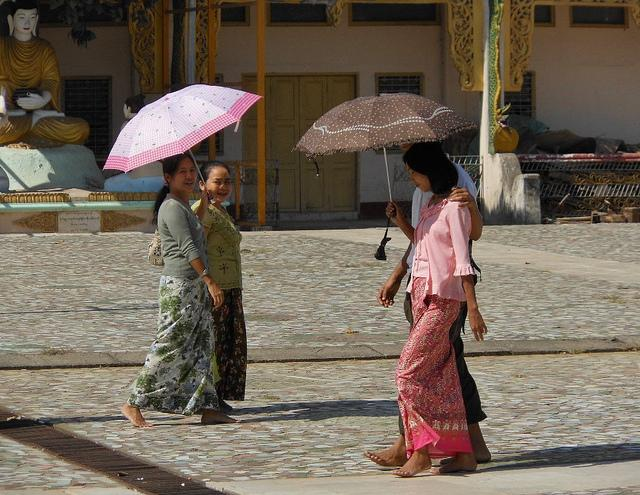Why are umbrellas being used today? Please explain your reasoning. sun. Though traditionally umbrellas are used for rain, but it's a sunny day. 